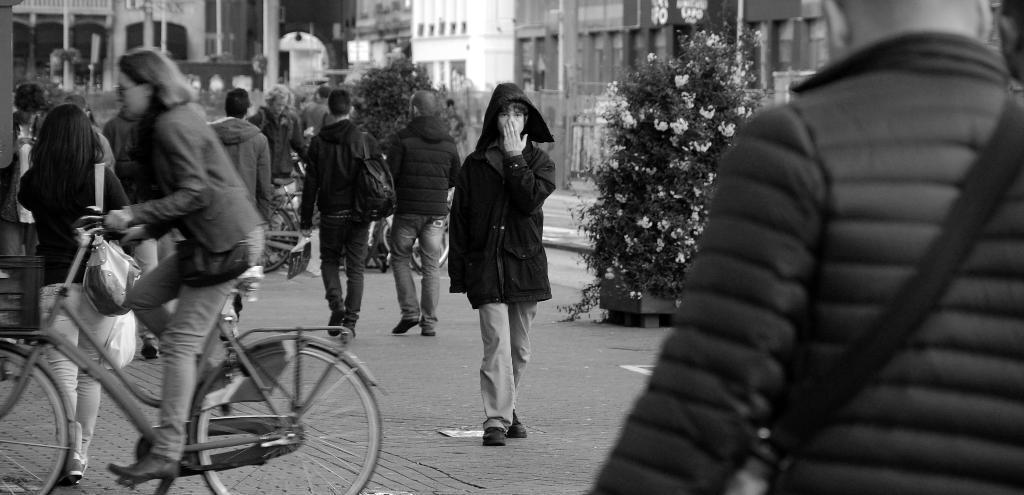Could you give a brief overview of what you see in this image? A lady wearing a bag is riding a cycle. There are many persons are walking on the road. In the front a person is wearing jacket. On the sides there are trees with flower. In the background there are buildings. 